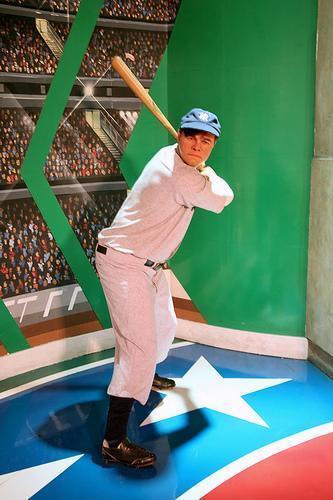How many wax figures are in the picture?
Give a very brief answer. 1. 